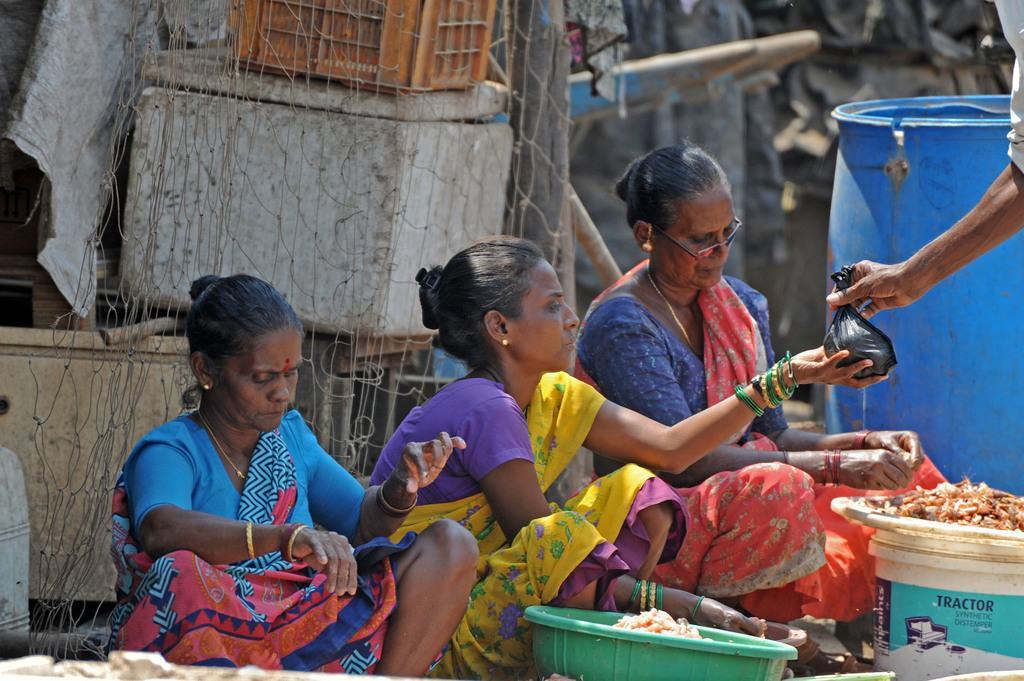How would you summarize this image in a sentence or two? In this image we can see people, drum, basket, box, mesh, container, bucket and things. Background it is blur. A person is holding a plastic bag. 